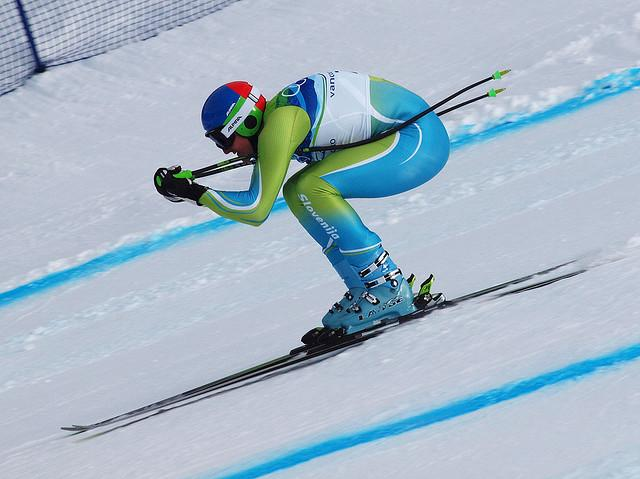What is this person trying to do? Please explain your reasoning. descend. They are headed rapidly down a steep hill. 